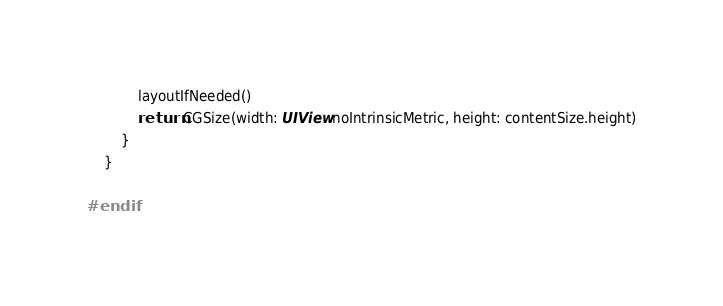<code> <loc_0><loc_0><loc_500><loc_500><_Swift_>            layoutIfNeeded()
            return CGSize(width: UIView.noIntrinsicMetric, height: contentSize.height)
        }
    }

#endif
</code> 